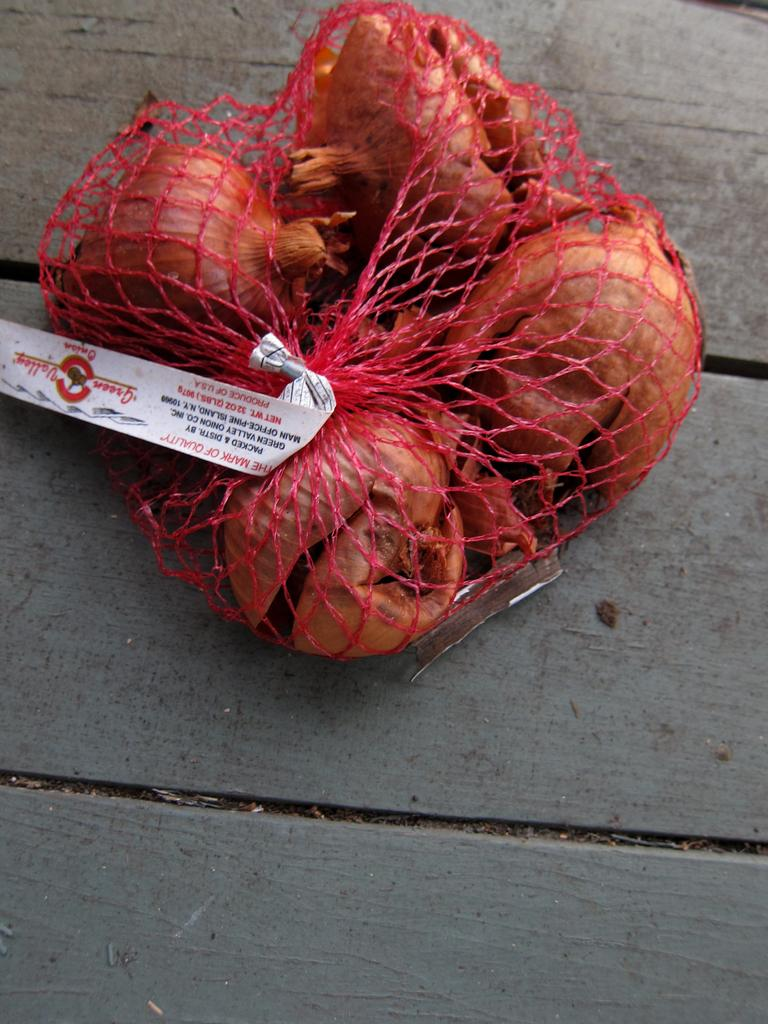What type of food items are present in the image? There are fruits in the image. How are the fruits arranged or contained? The fruits are packed in a net. What is the color of the net? The net is pink in color. Is there any additional information or labeling on the net? Yes, there is a sticker attached to the net. On what surface is the net placed? The net is on a wooden surface. How many brothers are depicted playing with the kite in the image? There are no brothers or kite present in the image. What type of detail can be seen on the fruits in the image? There is no specific detail mentioned about the fruits in the image, only that they are packed in a pink net. 